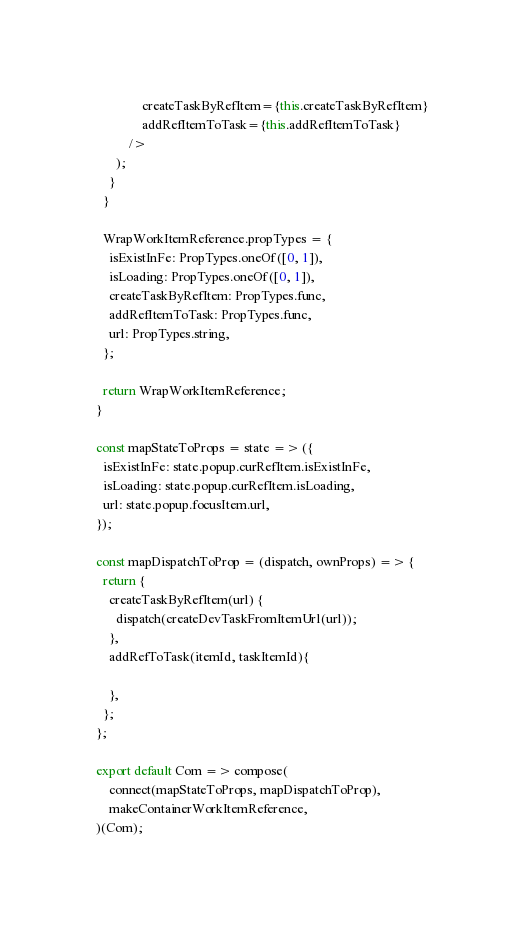<code> <loc_0><loc_0><loc_500><loc_500><_JavaScript_>              createTaskByRefItem={this.createTaskByRefItem}
              addRefItemToTask={this.addRefItemToTask}
          />
      );
    }
  }

  WrapWorkItemReference.propTypes = {
    isExistInFe: PropTypes.oneOf([0, 1]),
    isLoading: PropTypes.oneOf([0, 1]),
    createTaskByRefItem: PropTypes.func,
    addRefItemToTask: PropTypes.func,
    url: PropTypes.string,
  };

  return WrapWorkItemReference;
}

const mapStateToProps = state => ({
  isExistInFe: state.popup.curRefItem.isExistInFe,
  isLoading: state.popup.curRefItem.isLoading,
  url: state.popup.focusItem.url,
});

const mapDispatchToProp = (dispatch, ownProps) => {
  return {
    createTaskByRefItem(url) {
      dispatch(createDevTaskFromItemUrl(url));
    },
    addRefToTask(itemId, taskItemId){

    },
  };
};

export default Com => compose(
    connect(mapStateToProps, mapDispatchToProp),
    makeContainerWorkItemReference,
)(Com);
</code> 